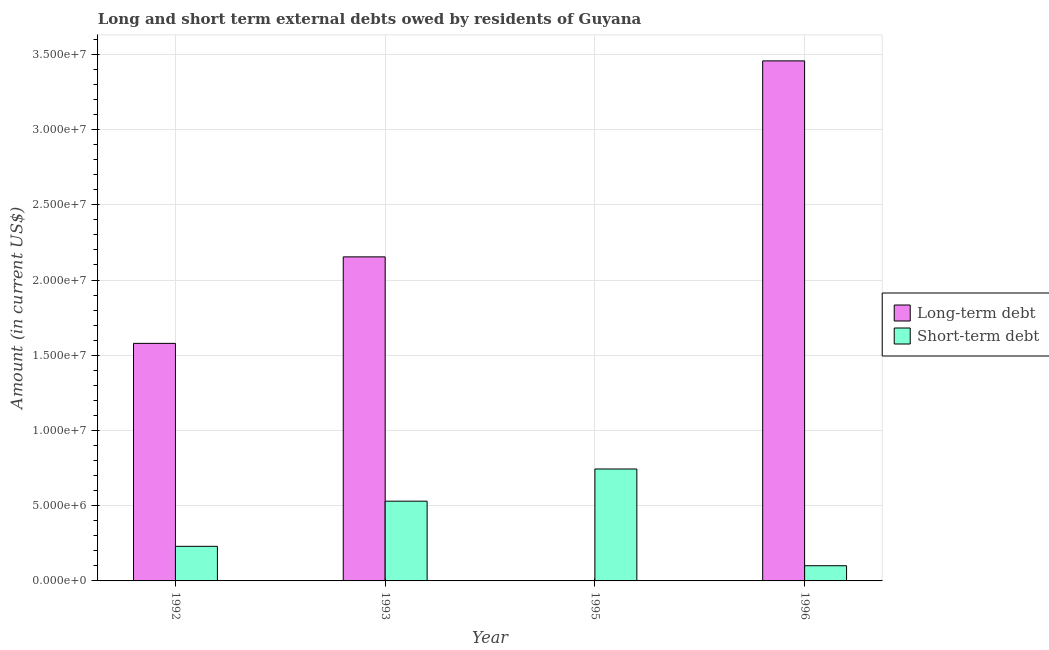Are the number of bars per tick equal to the number of legend labels?
Your answer should be compact. No. How many bars are there on the 2nd tick from the left?
Keep it short and to the point. 2. How many bars are there on the 1st tick from the right?
Ensure brevity in your answer.  2. What is the label of the 2nd group of bars from the left?
Ensure brevity in your answer.  1993. In how many cases, is the number of bars for a given year not equal to the number of legend labels?
Offer a terse response. 1. What is the short-term debts owed by residents in 1995?
Make the answer very short. 7.44e+06. Across all years, what is the maximum long-term debts owed by residents?
Offer a terse response. 3.46e+07. Across all years, what is the minimum long-term debts owed by residents?
Keep it short and to the point. 0. What is the total short-term debts owed by residents in the graph?
Offer a very short reply. 1.60e+07. What is the difference between the short-term debts owed by residents in 1995 and that in 1996?
Offer a terse response. 6.43e+06. What is the difference between the short-term debts owed by residents in 1993 and the long-term debts owed by residents in 1996?
Your answer should be compact. 4.29e+06. What is the average long-term debts owed by residents per year?
Offer a very short reply. 1.80e+07. In the year 1992, what is the difference between the long-term debts owed by residents and short-term debts owed by residents?
Provide a short and direct response. 0. In how many years, is the long-term debts owed by residents greater than 12000000 US$?
Your answer should be very brief. 3. What is the ratio of the short-term debts owed by residents in 1995 to that in 1996?
Provide a short and direct response. 7.37. What is the difference between the highest and the second highest long-term debts owed by residents?
Your response must be concise. 1.30e+07. What is the difference between the highest and the lowest long-term debts owed by residents?
Make the answer very short. 3.46e+07. In how many years, is the long-term debts owed by residents greater than the average long-term debts owed by residents taken over all years?
Offer a very short reply. 2. Is the sum of the long-term debts owed by residents in 1993 and 1996 greater than the maximum short-term debts owed by residents across all years?
Your answer should be compact. Yes. Does the graph contain grids?
Give a very brief answer. Yes. How many legend labels are there?
Keep it short and to the point. 2. How are the legend labels stacked?
Ensure brevity in your answer.  Vertical. What is the title of the graph?
Provide a short and direct response. Long and short term external debts owed by residents of Guyana. What is the label or title of the X-axis?
Provide a succinct answer. Year. What is the Amount (in current US$) of Long-term debt in 1992?
Give a very brief answer. 1.58e+07. What is the Amount (in current US$) of Short-term debt in 1992?
Offer a very short reply. 2.30e+06. What is the Amount (in current US$) in Long-term debt in 1993?
Offer a very short reply. 2.15e+07. What is the Amount (in current US$) in Short-term debt in 1993?
Offer a very short reply. 5.30e+06. What is the Amount (in current US$) in Short-term debt in 1995?
Offer a terse response. 7.44e+06. What is the Amount (in current US$) in Long-term debt in 1996?
Keep it short and to the point. 3.46e+07. What is the Amount (in current US$) of Short-term debt in 1996?
Your response must be concise. 1.01e+06. Across all years, what is the maximum Amount (in current US$) in Long-term debt?
Give a very brief answer. 3.46e+07. Across all years, what is the maximum Amount (in current US$) of Short-term debt?
Keep it short and to the point. 7.44e+06. Across all years, what is the minimum Amount (in current US$) in Short-term debt?
Keep it short and to the point. 1.01e+06. What is the total Amount (in current US$) in Long-term debt in the graph?
Make the answer very short. 7.19e+07. What is the total Amount (in current US$) in Short-term debt in the graph?
Ensure brevity in your answer.  1.60e+07. What is the difference between the Amount (in current US$) in Long-term debt in 1992 and that in 1993?
Make the answer very short. -5.75e+06. What is the difference between the Amount (in current US$) of Short-term debt in 1992 and that in 1993?
Offer a very short reply. -3.00e+06. What is the difference between the Amount (in current US$) in Short-term debt in 1992 and that in 1995?
Provide a succinct answer. -5.14e+06. What is the difference between the Amount (in current US$) in Long-term debt in 1992 and that in 1996?
Provide a succinct answer. -1.88e+07. What is the difference between the Amount (in current US$) in Short-term debt in 1992 and that in 1996?
Provide a short and direct response. 1.29e+06. What is the difference between the Amount (in current US$) in Short-term debt in 1993 and that in 1995?
Your answer should be very brief. -2.14e+06. What is the difference between the Amount (in current US$) of Long-term debt in 1993 and that in 1996?
Ensure brevity in your answer.  -1.30e+07. What is the difference between the Amount (in current US$) in Short-term debt in 1993 and that in 1996?
Your response must be concise. 4.29e+06. What is the difference between the Amount (in current US$) in Short-term debt in 1995 and that in 1996?
Your response must be concise. 6.43e+06. What is the difference between the Amount (in current US$) in Long-term debt in 1992 and the Amount (in current US$) in Short-term debt in 1993?
Offer a very short reply. 1.05e+07. What is the difference between the Amount (in current US$) of Long-term debt in 1992 and the Amount (in current US$) of Short-term debt in 1995?
Your response must be concise. 8.35e+06. What is the difference between the Amount (in current US$) of Long-term debt in 1992 and the Amount (in current US$) of Short-term debt in 1996?
Give a very brief answer. 1.48e+07. What is the difference between the Amount (in current US$) in Long-term debt in 1993 and the Amount (in current US$) in Short-term debt in 1995?
Offer a terse response. 1.41e+07. What is the difference between the Amount (in current US$) of Long-term debt in 1993 and the Amount (in current US$) of Short-term debt in 1996?
Offer a very short reply. 2.05e+07. What is the average Amount (in current US$) of Long-term debt per year?
Offer a very short reply. 1.80e+07. What is the average Amount (in current US$) of Short-term debt per year?
Provide a short and direct response. 4.01e+06. In the year 1992, what is the difference between the Amount (in current US$) of Long-term debt and Amount (in current US$) of Short-term debt?
Provide a succinct answer. 1.35e+07. In the year 1993, what is the difference between the Amount (in current US$) of Long-term debt and Amount (in current US$) of Short-term debt?
Offer a very short reply. 1.62e+07. In the year 1996, what is the difference between the Amount (in current US$) of Long-term debt and Amount (in current US$) of Short-term debt?
Your answer should be compact. 3.36e+07. What is the ratio of the Amount (in current US$) in Long-term debt in 1992 to that in 1993?
Your answer should be compact. 0.73. What is the ratio of the Amount (in current US$) in Short-term debt in 1992 to that in 1993?
Offer a terse response. 0.43. What is the ratio of the Amount (in current US$) of Short-term debt in 1992 to that in 1995?
Make the answer very short. 0.31. What is the ratio of the Amount (in current US$) in Long-term debt in 1992 to that in 1996?
Ensure brevity in your answer.  0.46. What is the ratio of the Amount (in current US$) in Short-term debt in 1992 to that in 1996?
Your answer should be very brief. 2.28. What is the ratio of the Amount (in current US$) in Short-term debt in 1993 to that in 1995?
Offer a terse response. 0.71. What is the ratio of the Amount (in current US$) in Long-term debt in 1993 to that in 1996?
Offer a very short reply. 0.62. What is the ratio of the Amount (in current US$) in Short-term debt in 1993 to that in 1996?
Provide a short and direct response. 5.25. What is the ratio of the Amount (in current US$) of Short-term debt in 1995 to that in 1996?
Offer a very short reply. 7.37. What is the difference between the highest and the second highest Amount (in current US$) of Long-term debt?
Your answer should be compact. 1.30e+07. What is the difference between the highest and the second highest Amount (in current US$) in Short-term debt?
Provide a succinct answer. 2.14e+06. What is the difference between the highest and the lowest Amount (in current US$) of Long-term debt?
Your answer should be compact. 3.46e+07. What is the difference between the highest and the lowest Amount (in current US$) in Short-term debt?
Keep it short and to the point. 6.43e+06. 